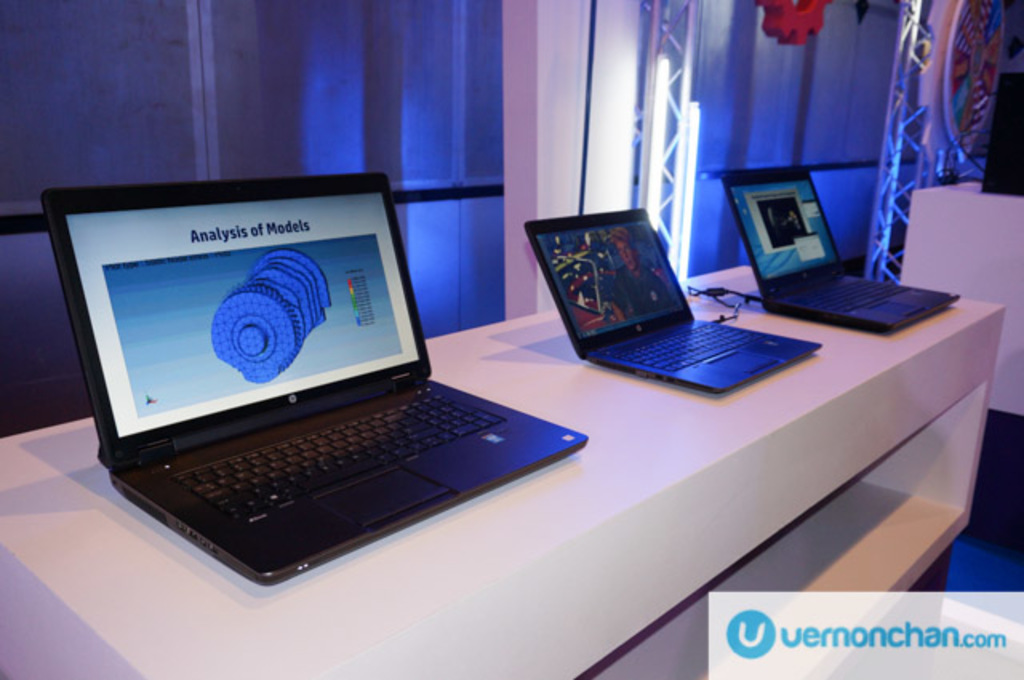Provide a one-sentence caption for the provided image. Three laptops displayed on a white table at a tech exhibition, the foremost laptop showcasing a graphic titled 'Analysis of Models' on its screen, illustrating a complex 3D model. 